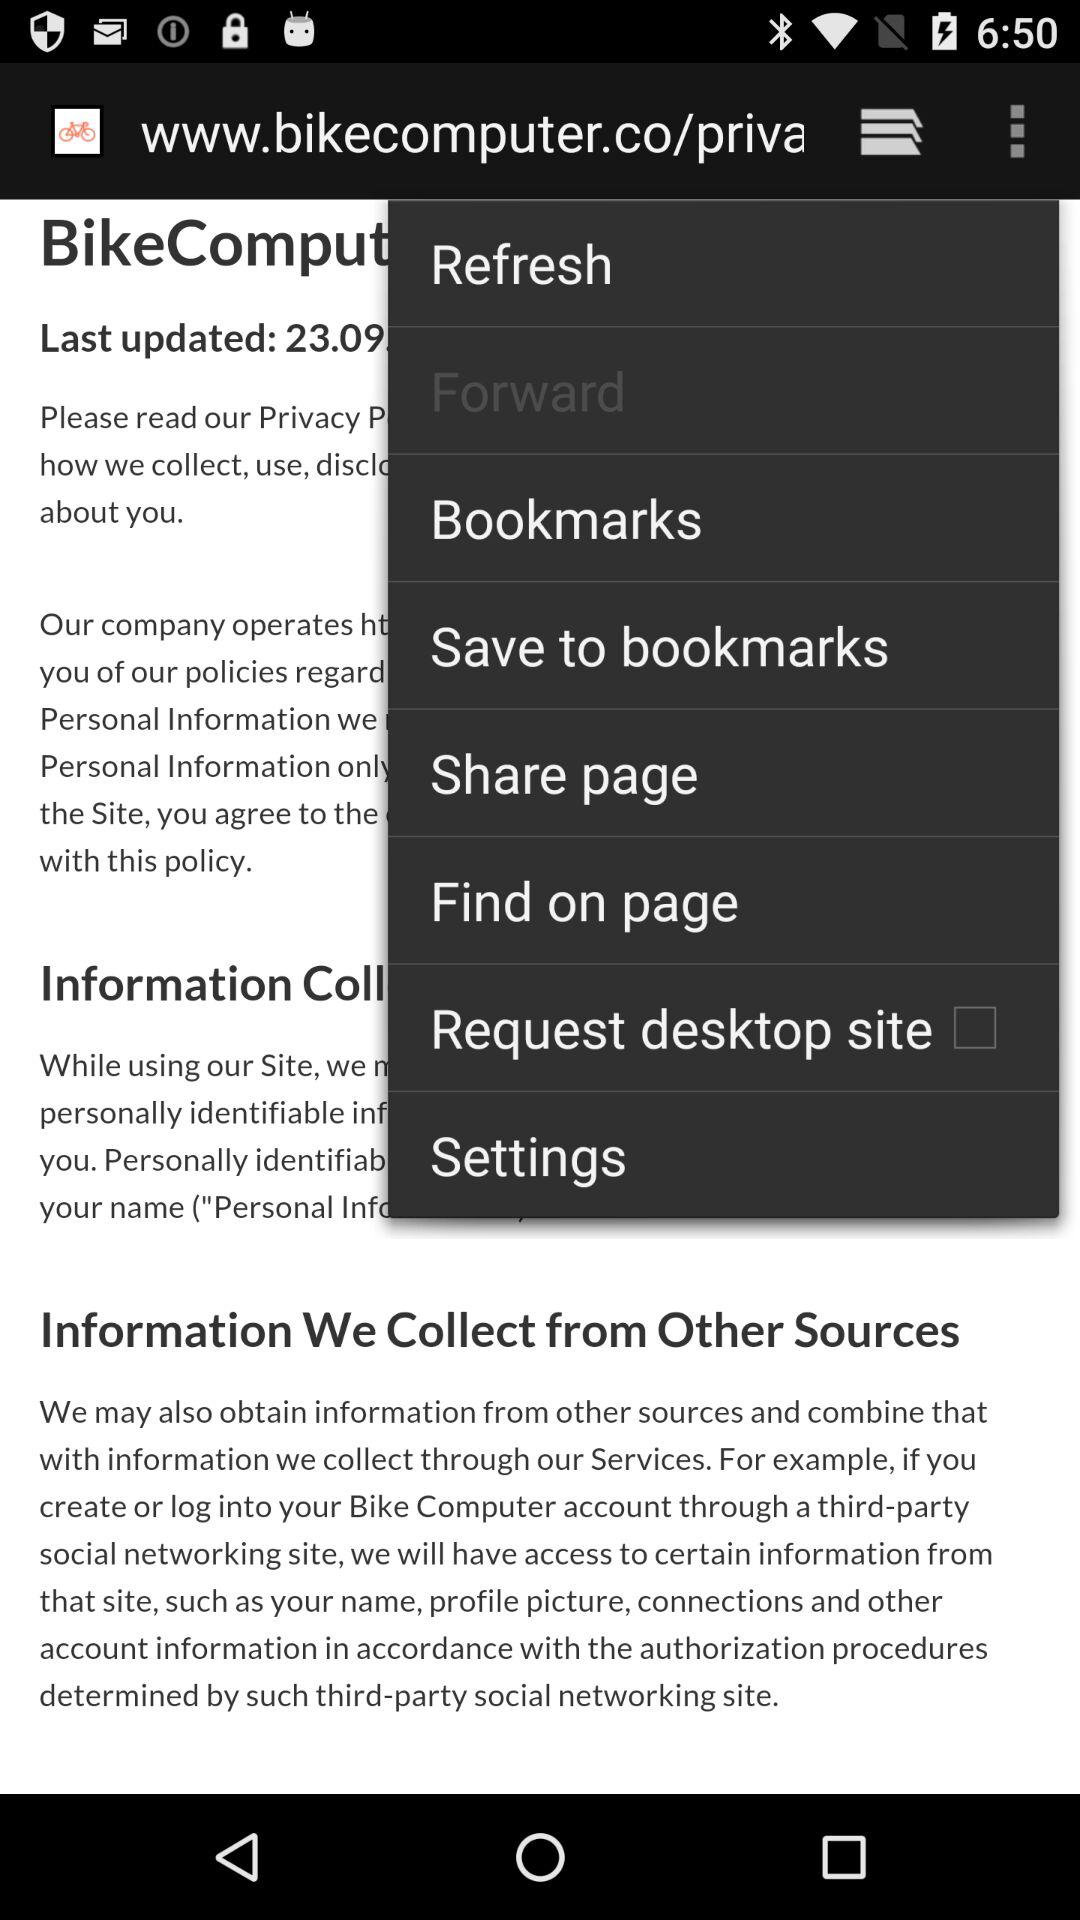What is the status of "Request desktop site"? The status is "off". 